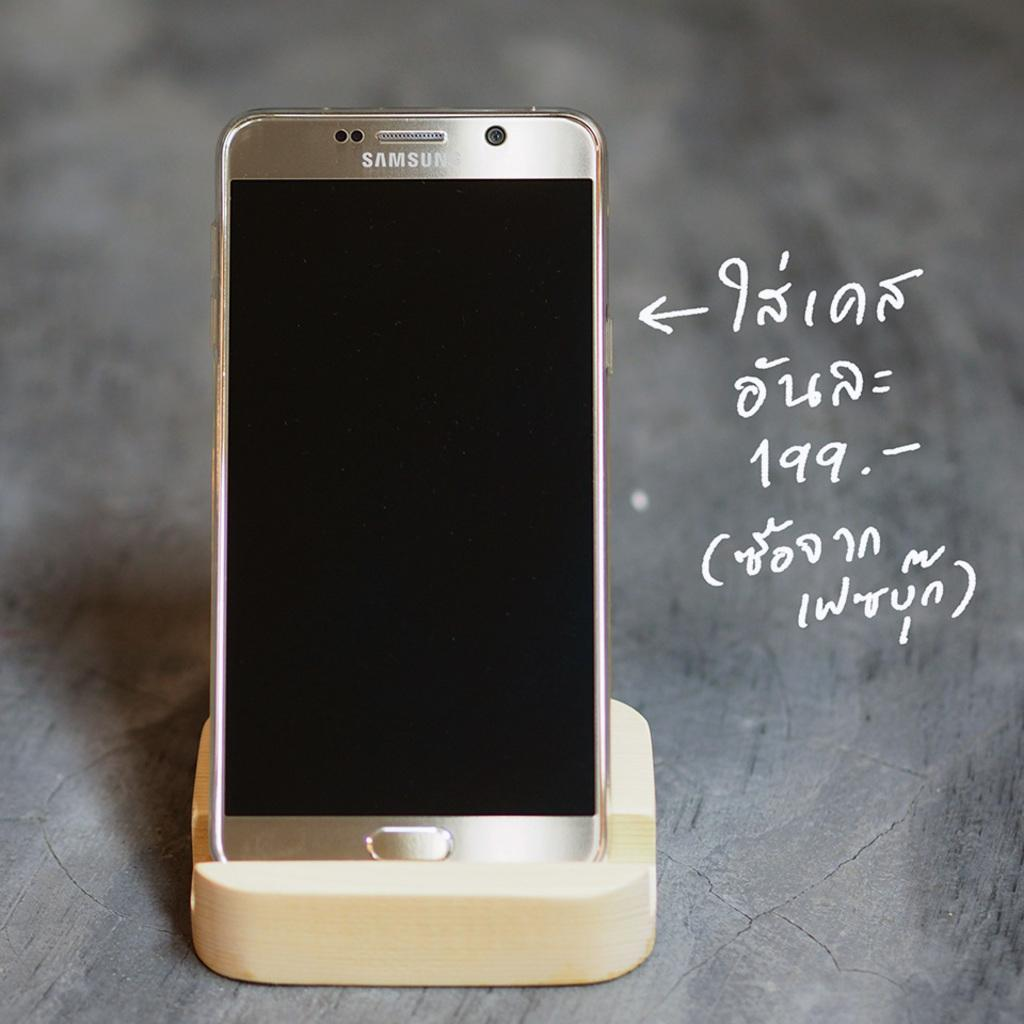<image>
Summarize the visual content of the image. A Samsung phone sits upright on a stand, next to some white writing. 